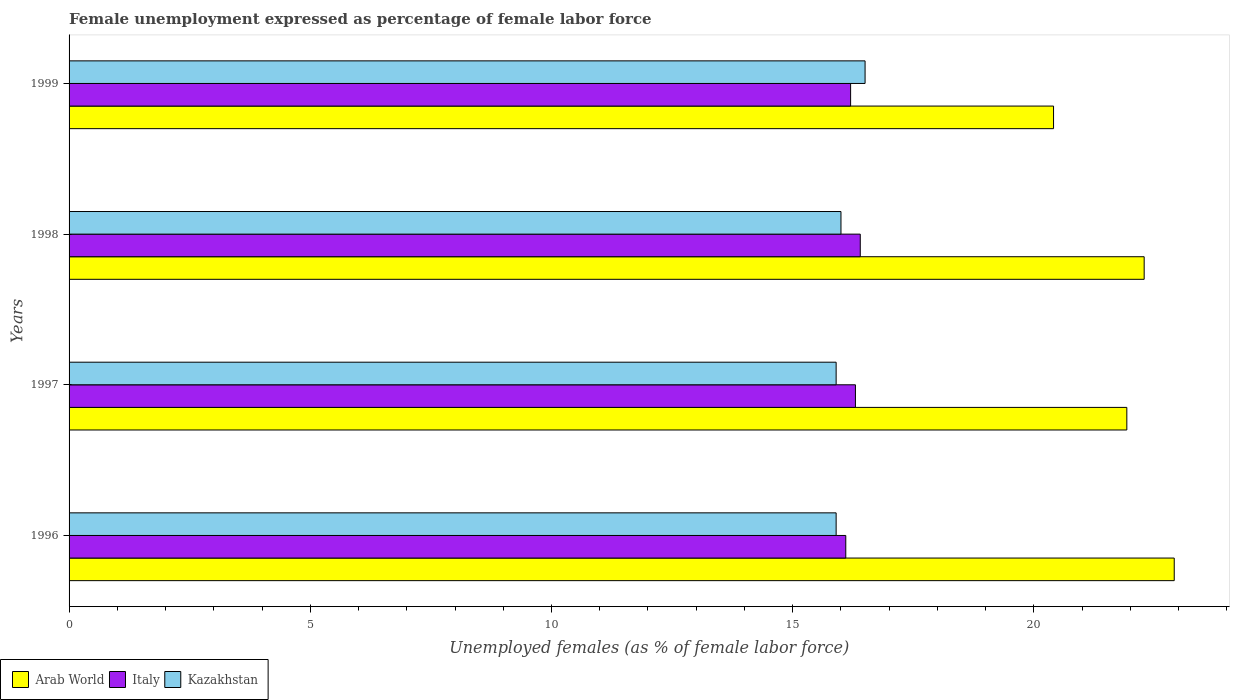Are the number of bars per tick equal to the number of legend labels?
Offer a terse response. Yes. How many bars are there on the 4th tick from the top?
Give a very brief answer. 3. How many bars are there on the 1st tick from the bottom?
Ensure brevity in your answer.  3. What is the label of the 3rd group of bars from the top?
Ensure brevity in your answer.  1997. What is the unemployment in females in in Kazakhstan in 1996?
Give a very brief answer. 15.9. Across all years, what is the maximum unemployment in females in in Italy?
Give a very brief answer. 16.4. Across all years, what is the minimum unemployment in females in in Italy?
Your response must be concise. 16.1. In which year was the unemployment in females in in Arab World minimum?
Your answer should be very brief. 1999. What is the total unemployment in females in in Kazakhstan in the graph?
Give a very brief answer. 64.3. What is the difference between the unemployment in females in in Italy in 1998 and that in 1999?
Offer a very short reply. 0.2. What is the difference between the unemployment in females in in Italy in 1998 and the unemployment in females in in Arab World in 1997?
Make the answer very short. -5.53. What is the average unemployment in females in in Arab World per year?
Offer a terse response. 21.88. In the year 1998, what is the difference between the unemployment in females in in Arab World and unemployment in females in in Italy?
Offer a terse response. 5.88. What is the ratio of the unemployment in females in in Arab World in 1996 to that in 1999?
Keep it short and to the point. 1.12. Is the difference between the unemployment in females in in Arab World in 1997 and 1999 greater than the difference between the unemployment in females in in Italy in 1997 and 1999?
Keep it short and to the point. Yes. What is the difference between the highest and the lowest unemployment in females in in Kazakhstan?
Your answer should be compact. 0.6. Is the sum of the unemployment in females in in Kazakhstan in 1996 and 1997 greater than the maximum unemployment in females in in Italy across all years?
Ensure brevity in your answer.  Yes. What does the 1st bar from the top in 1997 represents?
Offer a very short reply. Kazakhstan. What does the 3rd bar from the bottom in 1999 represents?
Your answer should be very brief. Kazakhstan. Is it the case that in every year, the sum of the unemployment in females in in Kazakhstan and unemployment in females in in Arab World is greater than the unemployment in females in in Italy?
Your answer should be very brief. Yes. How many bars are there?
Your response must be concise. 12. Does the graph contain any zero values?
Your answer should be very brief. No. Where does the legend appear in the graph?
Ensure brevity in your answer.  Bottom left. How many legend labels are there?
Offer a terse response. 3. How are the legend labels stacked?
Give a very brief answer. Horizontal. What is the title of the graph?
Make the answer very short. Female unemployment expressed as percentage of female labor force. Does "Ireland" appear as one of the legend labels in the graph?
Your answer should be compact. No. What is the label or title of the X-axis?
Provide a short and direct response. Unemployed females (as % of female labor force). What is the Unemployed females (as % of female labor force) in Arab World in 1996?
Provide a succinct answer. 22.91. What is the Unemployed females (as % of female labor force) of Italy in 1996?
Ensure brevity in your answer.  16.1. What is the Unemployed females (as % of female labor force) in Kazakhstan in 1996?
Provide a short and direct response. 15.9. What is the Unemployed females (as % of female labor force) of Arab World in 1997?
Ensure brevity in your answer.  21.93. What is the Unemployed females (as % of female labor force) of Italy in 1997?
Your answer should be compact. 16.3. What is the Unemployed females (as % of female labor force) in Kazakhstan in 1997?
Your answer should be compact. 15.9. What is the Unemployed females (as % of female labor force) of Arab World in 1998?
Your answer should be compact. 22.28. What is the Unemployed females (as % of female labor force) of Italy in 1998?
Provide a succinct answer. 16.4. What is the Unemployed females (as % of female labor force) in Kazakhstan in 1998?
Your response must be concise. 16. What is the Unemployed females (as % of female labor force) in Arab World in 1999?
Give a very brief answer. 20.41. What is the Unemployed females (as % of female labor force) in Italy in 1999?
Your answer should be compact. 16.2. Across all years, what is the maximum Unemployed females (as % of female labor force) in Arab World?
Provide a succinct answer. 22.91. Across all years, what is the maximum Unemployed females (as % of female labor force) in Italy?
Offer a very short reply. 16.4. Across all years, what is the maximum Unemployed females (as % of female labor force) in Kazakhstan?
Your answer should be compact. 16.5. Across all years, what is the minimum Unemployed females (as % of female labor force) in Arab World?
Give a very brief answer. 20.41. Across all years, what is the minimum Unemployed females (as % of female labor force) in Italy?
Provide a short and direct response. 16.1. Across all years, what is the minimum Unemployed females (as % of female labor force) in Kazakhstan?
Provide a short and direct response. 15.9. What is the total Unemployed females (as % of female labor force) of Arab World in the graph?
Ensure brevity in your answer.  87.53. What is the total Unemployed females (as % of female labor force) in Italy in the graph?
Your answer should be very brief. 65. What is the total Unemployed females (as % of female labor force) in Kazakhstan in the graph?
Ensure brevity in your answer.  64.3. What is the difference between the Unemployed females (as % of female labor force) in Arab World in 1996 and that in 1997?
Provide a short and direct response. 0.98. What is the difference between the Unemployed females (as % of female labor force) in Kazakhstan in 1996 and that in 1997?
Ensure brevity in your answer.  0. What is the difference between the Unemployed females (as % of female labor force) in Arab World in 1996 and that in 1998?
Keep it short and to the point. 0.62. What is the difference between the Unemployed females (as % of female labor force) in Arab World in 1996 and that in 1999?
Offer a very short reply. 2.5. What is the difference between the Unemployed females (as % of female labor force) of Italy in 1996 and that in 1999?
Offer a terse response. -0.1. What is the difference between the Unemployed females (as % of female labor force) in Arab World in 1997 and that in 1998?
Your answer should be very brief. -0.36. What is the difference between the Unemployed females (as % of female labor force) of Kazakhstan in 1997 and that in 1998?
Provide a succinct answer. -0.1. What is the difference between the Unemployed females (as % of female labor force) of Arab World in 1997 and that in 1999?
Ensure brevity in your answer.  1.52. What is the difference between the Unemployed females (as % of female labor force) of Italy in 1997 and that in 1999?
Your answer should be very brief. 0.1. What is the difference between the Unemployed females (as % of female labor force) in Kazakhstan in 1997 and that in 1999?
Your answer should be compact. -0.6. What is the difference between the Unemployed females (as % of female labor force) of Arab World in 1998 and that in 1999?
Your answer should be very brief. 1.88. What is the difference between the Unemployed females (as % of female labor force) in Italy in 1998 and that in 1999?
Make the answer very short. 0.2. What is the difference between the Unemployed females (as % of female labor force) of Arab World in 1996 and the Unemployed females (as % of female labor force) of Italy in 1997?
Offer a terse response. 6.61. What is the difference between the Unemployed females (as % of female labor force) of Arab World in 1996 and the Unemployed females (as % of female labor force) of Kazakhstan in 1997?
Provide a short and direct response. 7.01. What is the difference between the Unemployed females (as % of female labor force) in Italy in 1996 and the Unemployed females (as % of female labor force) in Kazakhstan in 1997?
Your answer should be very brief. 0.2. What is the difference between the Unemployed females (as % of female labor force) of Arab World in 1996 and the Unemployed females (as % of female labor force) of Italy in 1998?
Keep it short and to the point. 6.51. What is the difference between the Unemployed females (as % of female labor force) of Arab World in 1996 and the Unemployed females (as % of female labor force) of Kazakhstan in 1998?
Give a very brief answer. 6.91. What is the difference between the Unemployed females (as % of female labor force) of Arab World in 1996 and the Unemployed females (as % of female labor force) of Italy in 1999?
Provide a short and direct response. 6.71. What is the difference between the Unemployed females (as % of female labor force) of Arab World in 1996 and the Unemployed females (as % of female labor force) of Kazakhstan in 1999?
Keep it short and to the point. 6.41. What is the difference between the Unemployed females (as % of female labor force) in Italy in 1996 and the Unemployed females (as % of female labor force) in Kazakhstan in 1999?
Your response must be concise. -0.4. What is the difference between the Unemployed females (as % of female labor force) of Arab World in 1997 and the Unemployed females (as % of female labor force) of Italy in 1998?
Your response must be concise. 5.53. What is the difference between the Unemployed females (as % of female labor force) in Arab World in 1997 and the Unemployed females (as % of female labor force) in Kazakhstan in 1998?
Provide a short and direct response. 5.93. What is the difference between the Unemployed females (as % of female labor force) in Italy in 1997 and the Unemployed females (as % of female labor force) in Kazakhstan in 1998?
Ensure brevity in your answer.  0.3. What is the difference between the Unemployed females (as % of female labor force) of Arab World in 1997 and the Unemployed females (as % of female labor force) of Italy in 1999?
Keep it short and to the point. 5.73. What is the difference between the Unemployed females (as % of female labor force) of Arab World in 1997 and the Unemployed females (as % of female labor force) of Kazakhstan in 1999?
Offer a terse response. 5.43. What is the difference between the Unemployed females (as % of female labor force) in Arab World in 1998 and the Unemployed females (as % of female labor force) in Italy in 1999?
Make the answer very short. 6.08. What is the difference between the Unemployed females (as % of female labor force) in Arab World in 1998 and the Unemployed females (as % of female labor force) in Kazakhstan in 1999?
Provide a succinct answer. 5.78. What is the average Unemployed females (as % of female labor force) of Arab World per year?
Your answer should be very brief. 21.88. What is the average Unemployed females (as % of female labor force) in Italy per year?
Offer a terse response. 16.25. What is the average Unemployed females (as % of female labor force) in Kazakhstan per year?
Ensure brevity in your answer.  16.07. In the year 1996, what is the difference between the Unemployed females (as % of female labor force) in Arab World and Unemployed females (as % of female labor force) in Italy?
Offer a very short reply. 6.81. In the year 1996, what is the difference between the Unemployed females (as % of female labor force) of Arab World and Unemployed females (as % of female labor force) of Kazakhstan?
Your answer should be very brief. 7.01. In the year 1996, what is the difference between the Unemployed females (as % of female labor force) in Italy and Unemployed females (as % of female labor force) in Kazakhstan?
Provide a succinct answer. 0.2. In the year 1997, what is the difference between the Unemployed females (as % of female labor force) in Arab World and Unemployed females (as % of female labor force) in Italy?
Your answer should be compact. 5.63. In the year 1997, what is the difference between the Unemployed females (as % of female labor force) of Arab World and Unemployed females (as % of female labor force) of Kazakhstan?
Provide a succinct answer. 6.03. In the year 1998, what is the difference between the Unemployed females (as % of female labor force) in Arab World and Unemployed females (as % of female labor force) in Italy?
Your answer should be very brief. 5.88. In the year 1998, what is the difference between the Unemployed females (as % of female labor force) of Arab World and Unemployed females (as % of female labor force) of Kazakhstan?
Your response must be concise. 6.28. In the year 1998, what is the difference between the Unemployed females (as % of female labor force) of Italy and Unemployed females (as % of female labor force) of Kazakhstan?
Ensure brevity in your answer.  0.4. In the year 1999, what is the difference between the Unemployed females (as % of female labor force) of Arab World and Unemployed females (as % of female labor force) of Italy?
Offer a terse response. 4.21. In the year 1999, what is the difference between the Unemployed females (as % of female labor force) in Arab World and Unemployed females (as % of female labor force) in Kazakhstan?
Your answer should be compact. 3.91. What is the ratio of the Unemployed females (as % of female labor force) in Arab World in 1996 to that in 1997?
Ensure brevity in your answer.  1.04. What is the ratio of the Unemployed females (as % of female labor force) of Italy in 1996 to that in 1997?
Offer a terse response. 0.99. What is the ratio of the Unemployed females (as % of female labor force) of Arab World in 1996 to that in 1998?
Your answer should be compact. 1.03. What is the ratio of the Unemployed females (as % of female labor force) in Italy in 1996 to that in 1998?
Provide a succinct answer. 0.98. What is the ratio of the Unemployed females (as % of female labor force) of Arab World in 1996 to that in 1999?
Provide a succinct answer. 1.12. What is the ratio of the Unemployed females (as % of female labor force) of Kazakhstan in 1996 to that in 1999?
Your answer should be very brief. 0.96. What is the ratio of the Unemployed females (as % of female labor force) in Arab World in 1997 to that in 1998?
Your answer should be compact. 0.98. What is the ratio of the Unemployed females (as % of female labor force) of Arab World in 1997 to that in 1999?
Provide a short and direct response. 1.07. What is the ratio of the Unemployed females (as % of female labor force) in Italy in 1997 to that in 1999?
Your answer should be very brief. 1.01. What is the ratio of the Unemployed females (as % of female labor force) in Kazakhstan in 1997 to that in 1999?
Provide a succinct answer. 0.96. What is the ratio of the Unemployed females (as % of female labor force) in Arab World in 1998 to that in 1999?
Ensure brevity in your answer.  1.09. What is the ratio of the Unemployed females (as % of female labor force) in Italy in 1998 to that in 1999?
Provide a short and direct response. 1.01. What is the ratio of the Unemployed females (as % of female labor force) in Kazakhstan in 1998 to that in 1999?
Your answer should be compact. 0.97. What is the difference between the highest and the second highest Unemployed females (as % of female labor force) of Arab World?
Ensure brevity in your answer.  0.62. What is the difference between the highest and the second highest Unemployed females (as % of female labor force) of Italy?
Ensure brevity in your answer.  0.1. What is the difference between the highest and the lowest Unemployed females (as % of female labor force) of Arab World?
Offer a very short reply. 2.5. What is the difference between the highest and the lowest Unemployed females (as % of female labor force) in Kazakhstan?
Offer a very short reply. 0.6. 